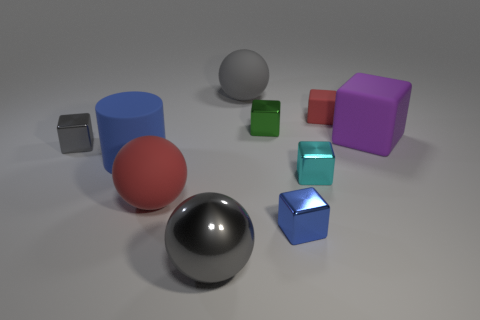Subtract all gray blocks. How many blocks are left? 5 Subtract all big purple blocks. How many blocks are left? 5 Subtract all gray blocks. Subtract all blue spheres. How many blocks are left? 5 Subtract all balls. How many objects are left? 7 Add 3 tiny gray matte things. How many tiny gray matte things exist? 3 Subtract 0 purple balls. How many objects are left? 10 Subtract all gray metallic blocks. Subtract all small blue metallic objects. How many objects are left? 8 Add 3 tiny cyan metal cubes. How many tiny cyan metal cubes are left? 4 